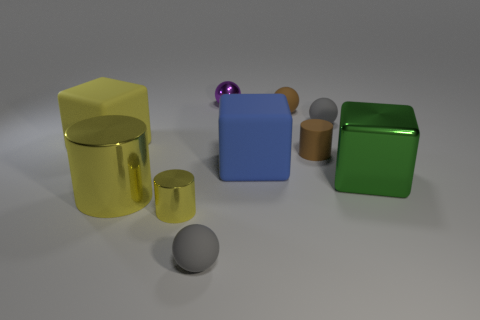Subtract all gray spheres. How many were subtracted if there are1gray spheres left? 1 Subtract all metal balls. How many balls are left? 3 Subtract all brown cylinders. How many cylinders are left? 2 Subtract all balls. How many objects are left? 6 Subtract 1 cylinders. How many cylinders are left? 2 Add 3 matte blocks. How many matte blocks exist? 5 Subtract 2 gray balls. How many objects are left? 8 Subtract all blue blocks. Subtract all brown balls. How many blocks are left? 2 Subtract all red cylinders. How many red blocks are left? 0 Subtract all yellow cylinders. Subtract all big yellow matte cubes. How many objects are left? 7 